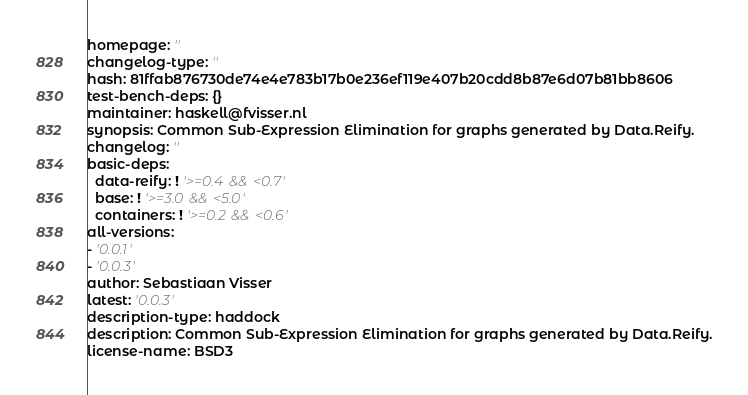<code> <loc_0><loc_0><loc_500><loc_500><_YAML_>homepage: ''
changelog-type: ''
hash: 81ffab876730de74e4e783b17b0e236ef119e407b20cdd8b87e6d07b81bb8606
test-bench-deps: {}
maintainer: haskell@fvisser.nl
synopsis: Common Sub-Expression Elimination for graphs generated by Data.Reify.
changelog: ''
basic-deps:
  data-reify: ! '>=0.4 && <0.7'
  base: ! '>=3.0 && <5.0'
  containers: ! '>=0.2 && <0.6'
all-versions:
- '0.0.1'
- '0.0.3'
author: Sebastiaan Visser
latest: '0.0.3'
description-type: haddock
description: Common Sub-Expression Elimination for graphs generated by Data.Reify.
license-name: BSD3
</code> 